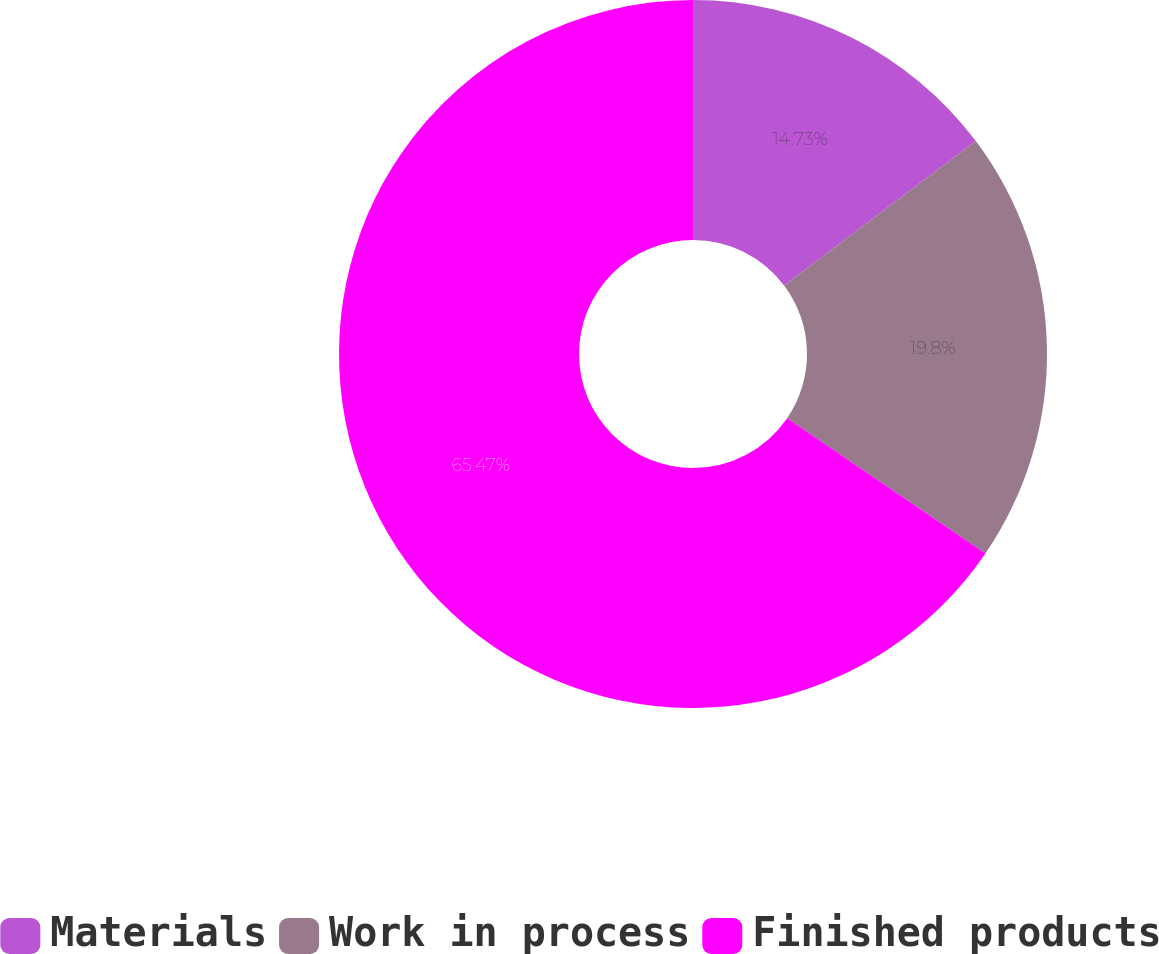Convert chart to OTSL. <chart><loc_0><loc_0><loc_500><loc_500><pie_chart><fcel>Materials<fcel>Work in process<fcel>Finished products<nl><fcel>14.73%<fcel>19.8%<fcel>65.47%<nl></chart> 